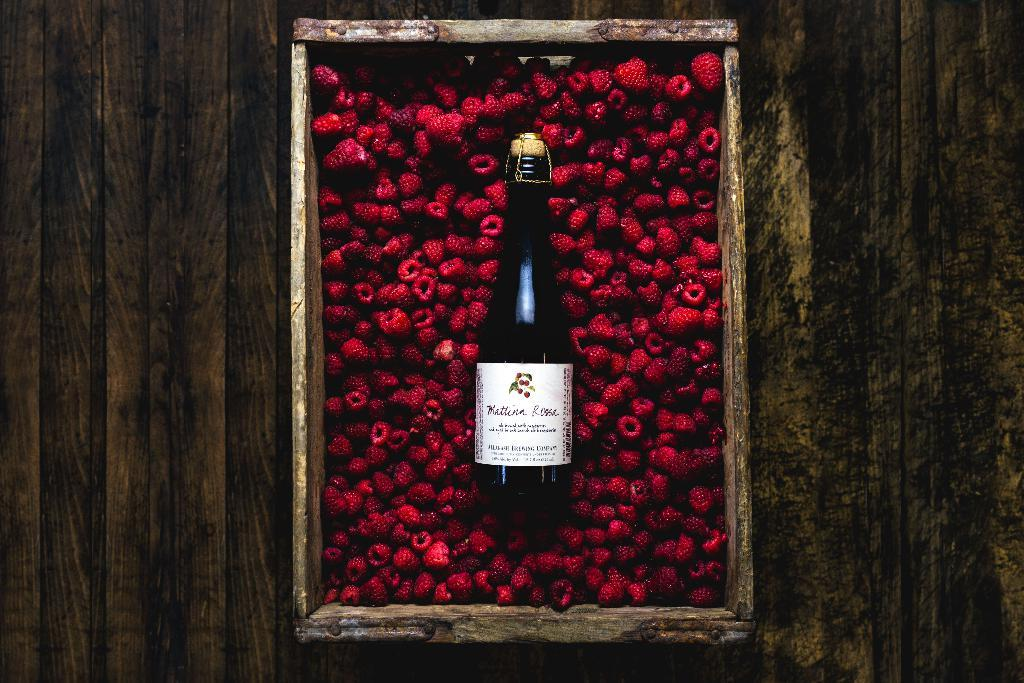Provide a one-sentence caption for the provided image. A bottle of Mattina Rossa in a container of red raspberries. 